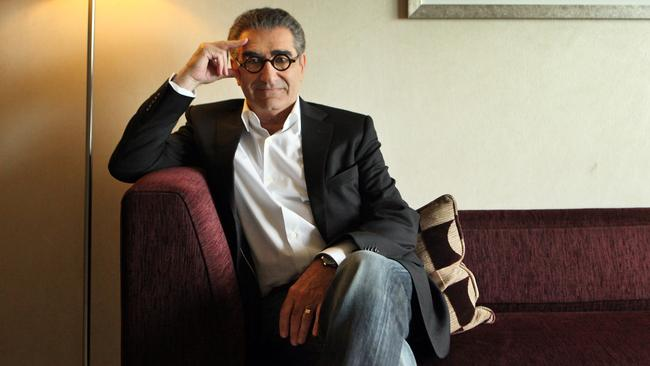What might the individual be contemplating about in this serene setting? Given his thoughtful expression and setting, he appears to be reflecting on matters either personal or professional. Perhaps he is contemplating a new creative project or reminiscing about significant moments in his career. 